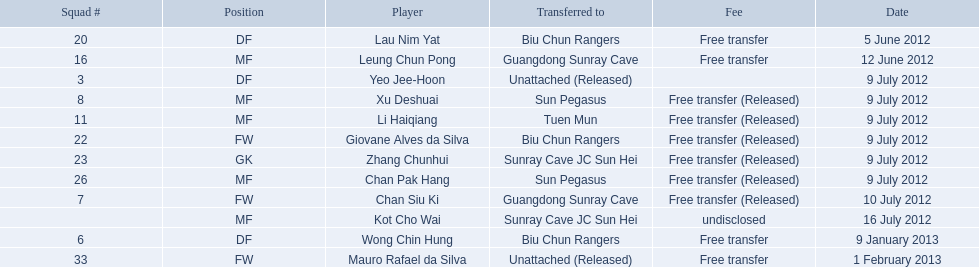On what days were there non-disclosed free transfers? 5 June 2012, 12 June 2012, 9 January 2013, 1 February 2013. On which of these were the players shifted to another team? 5 June 2012, 12 June 2012, 9 January 2013. Which of these were the transfers to biu chun rangers? 5 June 2012, 9 January 2013. On which of those dates did they acquire a df? 9 January 2013. 